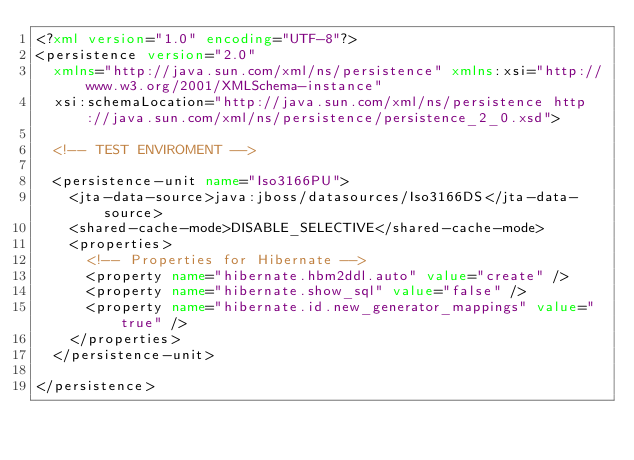Convert code to text. <code><loc_0><loc_0><loc_500><loc_500><_XML_><?xml version="1.0" encoding="UTF-8"?>
<persistence version="2.0"
	xmlns="http://java.sun.com/xml/ns/persistence" xmlns:xsi="http://www.w3.org/2001/XMLSchema-instance"
	xsi:schemaLocation="http://java.sun.com/xml/ns/persistence http://java.sun.com/xml/ns/persistence/persistence_2_0.xsd">

	<!-- TEST ENVIROMENT -->

	<persistence-unit name="Iso3166PU">
		<jta-data-source>java:jboss/datasources/Iso3166DS</jta-data-source>
		<shared-cache-mode>DISABLE_SELECTIVE</shared-cache-mode>
		<properties>
			<!-- Properties for Hibernate -->
			<property name="hibernate.hbm2ddl.auto" value="create" />
			<property name="hibernate.show_sql" value="false" />
			<property name="hibernate.id.new_generator_mappings" value="true" />
		</properties>
	</persistence-unit>

</persistence></code> 